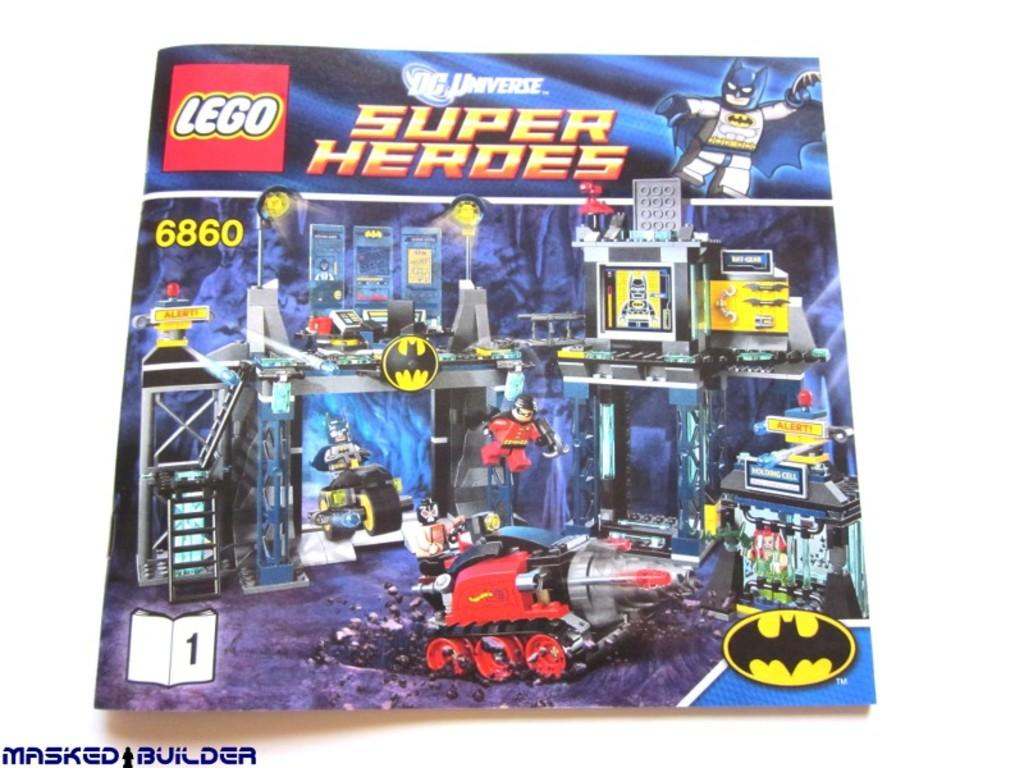What is present on the poster in the image? There is a poster in the image, with something written on it and animation images. What additional feature can be seen on the poster? There is a watermark on the poster. What is the color of the background in the image? The background of the image is white. How many boats are visible in the image? There are no boats present in the image; it features a poster with animation images. What type of jelly can be seen on the poster? There is no jelly present on the poster; it contains animation images and written content. 